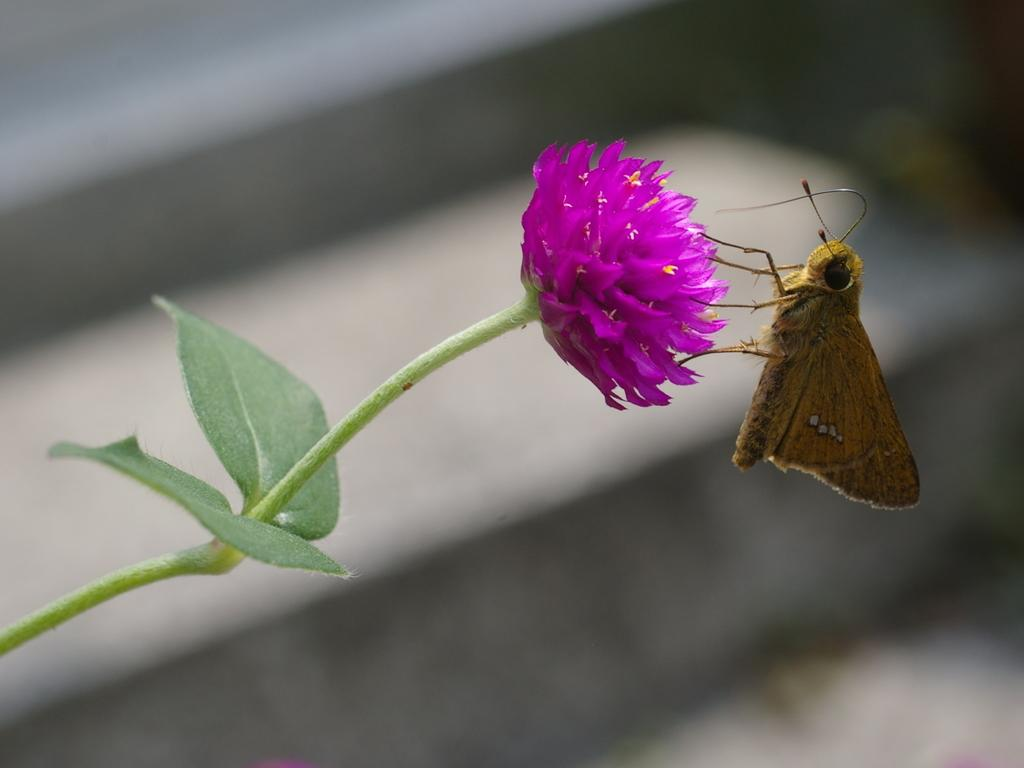What type of insect is in the image? There is a brown color butterfly in the image. What is the butterfly resting on? The butterfly is on a pink color flower. Can you describe the background of the image? The background of the image is blurred. What type of laborer can be seen working in the image? There is no laborer present in the image; it features a brown butterfly on a pink flower with a blurred background. What type of polish is visible on the flower in the image? There is no polish present in the image; it features a brown butterfly on a pink flower with a blurred background. 